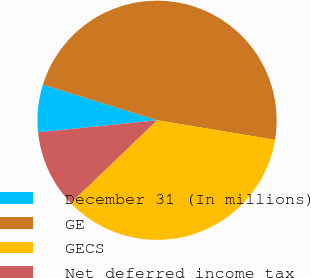Convert chart. <chart><loc_0><loc_0><loc_500><loc_500><pie_chart><fcel>December 31 (In millions)<fcel>GE<fcel>GECS<fcel>Net deferred income tax<nl><fcel>6.43%<fcel>47.8%<fcel>35.21%<fcel>10.56%<nl></chart> 